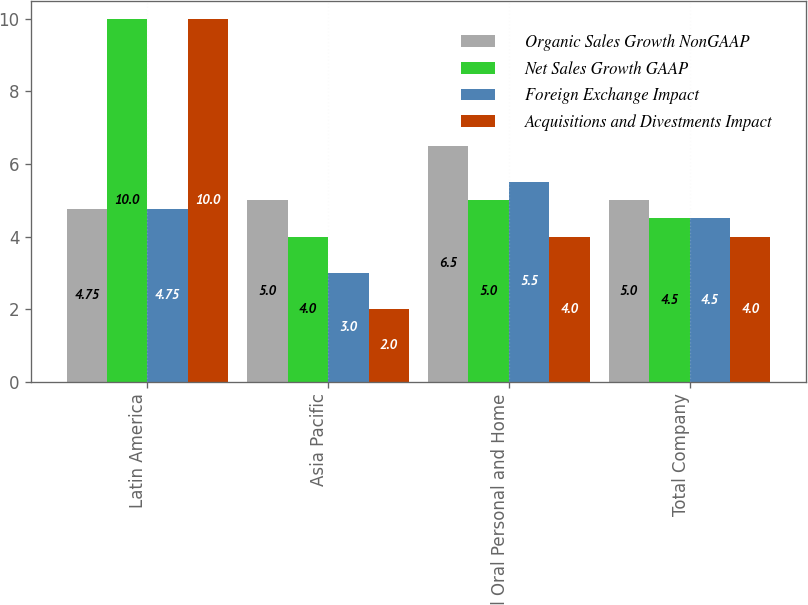<chart> <loc_0><loc_0><loc_500><loc_500><stacked_bar_chart><ecel><fcel>Latin America<fcel>Asia Pacific<fcel>Total Oral Personal and Home<fcel>Total Company<nl><fcel>Organic Sales Growth NonGAAP<fcel>4.75<fcel>5<fcel>6.5<fcel>5<nl><fcel>Net Sales Growth GAAP<fcel>10<fcel>4<fcel>5<fcel>4.5<nl><fcel>Foreign Exchange Impact<fcel>4.75<fcel>3<fcel>5.5<fcel>4.5<nl><fcel>Acquisitions and Divestments Impact<fcel>10<fcel>2<fcel>4<fcel>4<nl></chart> 